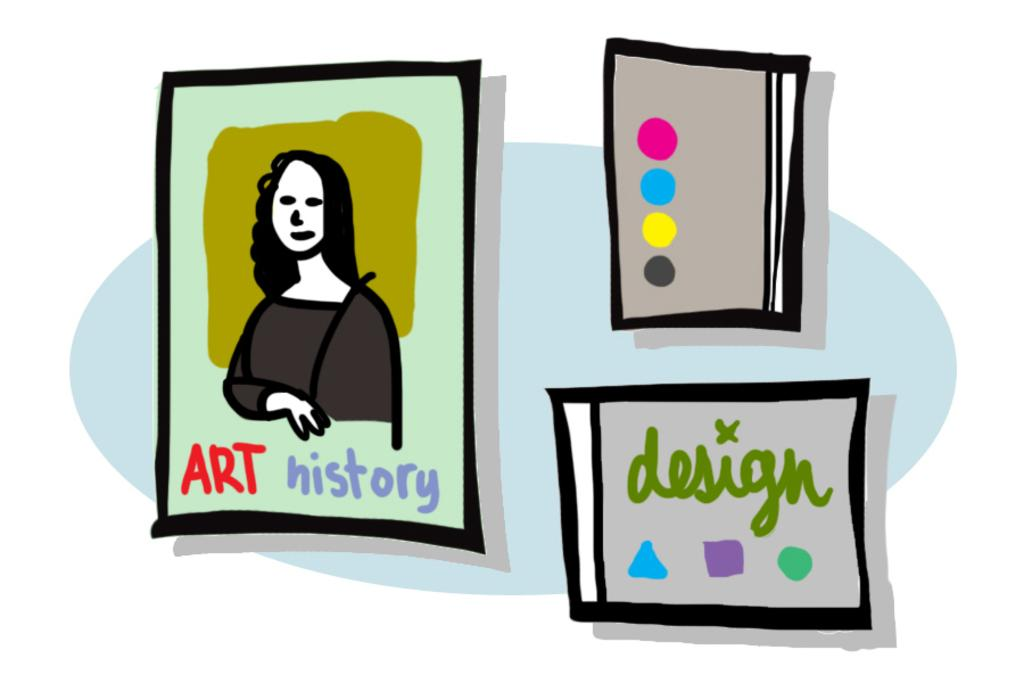What is the main subject of the image? The main subject of the image is a clip art. What is depicted within the clip art? The clip art contains a depiction of a person. Are there any words or letters within the clip art? Yes, there is text present in the clip art. What type of furniture can be seen in the image? There is no furniture present in the image; it features a clip art with a person and text. Can you tell me how many astronauts are depicted in the image? There are no astronauts or any space-related elements present in the image. How many times do the people in the image kiss each other? There are no people kissing in the image; it features a clip art with a person and text. 